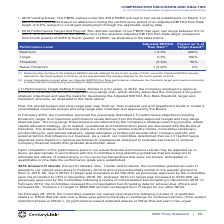According to Centurylink's financial document, How is the Adjusted EBITDA Run Rate determined? Determined by dividing (i) the Adjusted EBITDA actually attained for the fourth quarter of 2020 minus the Adjusted EBITDA actually attained for the fourth quarter of 2018 by (ii) the Adjusted EBITDA actually attained for the fourth quarter of 2018. The document states: "(1) Determined by dividing (i) the Adjusted EBITDA actually attained for the fourth quarter of 2020 minus the Adjusted EBITDA actually attained for th..." Also, When determining the payout as a % of the target award, when is linear interpolation used? when our Adjusted EBITDA Run Rate performance is between the threshold, target and maximum amounts. The document states: "(2) Linear interpolation is used when our Adjusted EBITDA Run Rate performance is between the threshold, target and maximum amounts to determine the c..." Also, What are the different performance levels? The document contains multiple relevant values: Maximum, Target, Threshold, Below Threshold. From the document: "Below Threshold < (2.8)% 0% Maximum ≥ 2.8% 200% Below Threshold < (2.8)% 0% Target 0.0% 100%..." Also, How many different performance levels are there? Counting the relevant items in the document: Maximum, Target, Threshold, Below Threshold, I find 4 instances. The key data points involved are: Below Threshold, Maximum, Target. Also, How many performance levels would the payout as % of target award be above 50%? Counting the relevant items in the document: Maximum, Target, I find 2 instances. The key data points involved are: Maximum, Target. Also, can you calculate: What is the difference in the ratios of the payout expressed as % of Target Award for Maximum over Target compared against Target over Threshold? I cannot find a specific answer to this question in the financial document. 